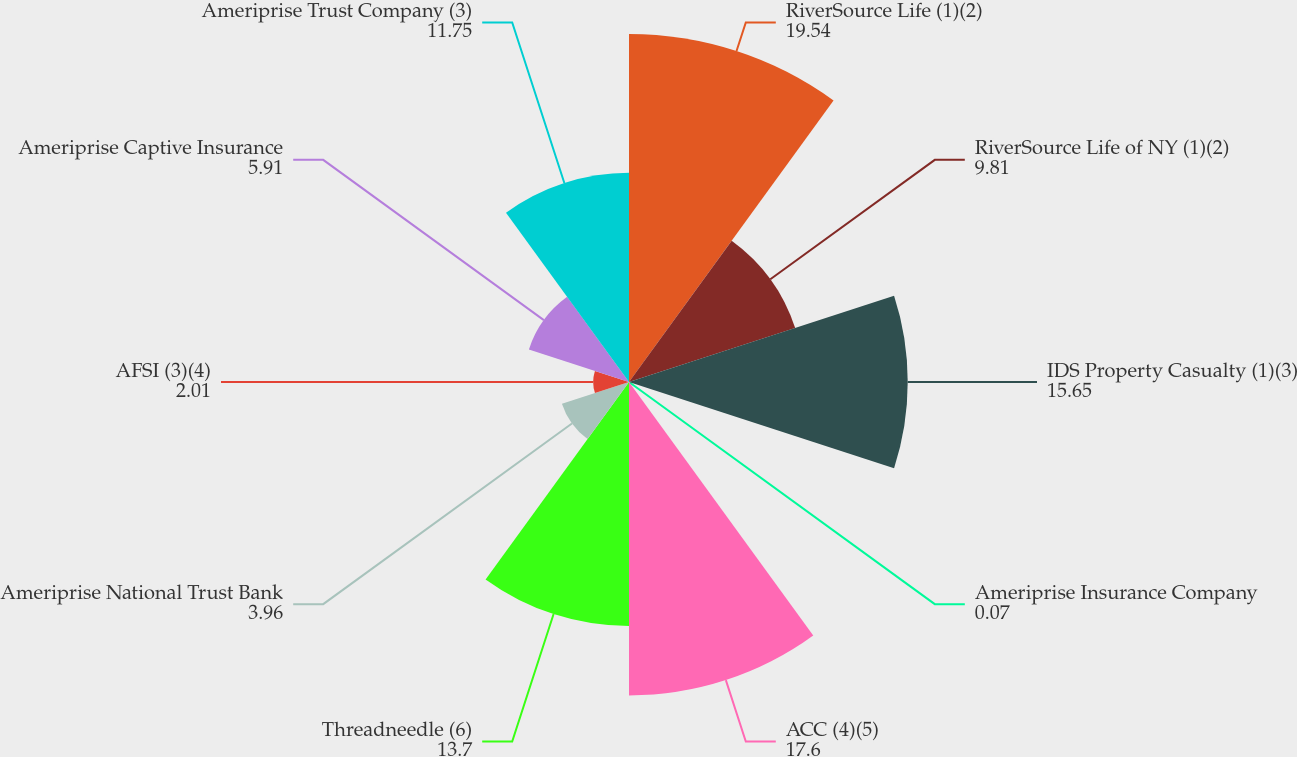Convert chart to OTSL. <chart><loc_0><loc_0><loc_500><loc_500><pie_chart><fcel>RiverSource Life (1)(2)<fcel>RiverSource Life of NY (1)(2)<fcel>IDS Property Casualty (1)(3)<fcel>Ameriprise Insurance Company<fcel>ACC (4)(5)<fcel>Threadneedle (6)<fcel>Ameriprise National Trust Bank<fcel>AFSI (3)(4)<fcel>Ameriprise Captive Insurance<fcel>Ameriprise Trust Company (3)<nl><fcel>19.54%<fcel>9.81%<fcel>15.65%<fcel>0.07%<fcel>17.6%<fcel>13.7%<fcel>3.96%<fcel>2.01%<fcel>5.91%<fcel>11.75%<nl></chart> 